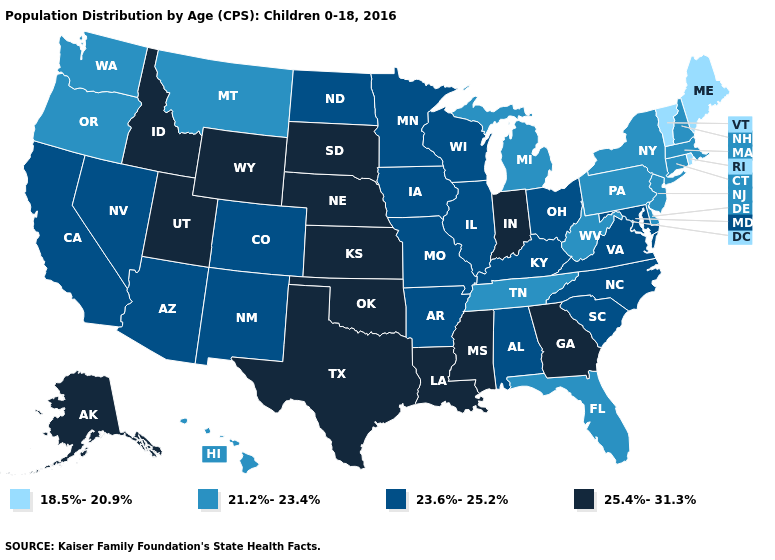Among the states that border Idaho , which have the highest value?
Be succinct. Utah, Wyoming. Does the first symbol in the legend represent the smallest category?
Concise answer only. Yes. Name the states that have a value in the range 18.5%-20.9%?
Keep it brief. Maine, Rhode Island, Vermont. Which states have the highest value in the USA?
Short answer required. Alaska, Georgia, Idaho, Indiana, Kansas, Louisiana, Mississippi, Nebraska, Oklahoma, South Dakota, Texas, Utah, Wyoming. What is the highest value in the USA?
Quick response, please. 25.4%-31.3%. What is the highest value in the USA?
Be succinct. 25.4%-31.3%. Name the states that have a value in the range 21.2%-23.4%?
Concise answer only. Connecticut, Delaware, Florida, Hawaii, Massachusetts, Michigan, Montana, New Hampshire, New Jersey, New York, Oregon, Pennsylvania, Tennessee, Washington, West Virginia. Which states have the highest value in the USA?
Short answer required. Alaska, Georgia, Idaho, Indiana, Kansas, Louisiana, Mississippi, Nebraska, Oklahoma, South Dakota, Texas, Utah, Wyoming. What is the value of Utah?
Be succinct. 25.4%-31.3%. What is the value of Arizona?
Answer briefly. 23.6%-25.2%. Name the states that have a value in the range 25.4%-31.3%?
Concise answer only. Alaska, Georgia, Idaho, Indiana, Kansas, Louisiana, Mississippi, Nebraska, Oklahoma, South Dakota, Texas, Utah, Wyoming. Among the states that border North Carolina , does Georgia have the lowest value?
Be succinct. No. Does the first symbol in the legend represent the smallest category?
Short answer required. Yes. What is the highest value in states that border North Dakota?
Give a very brief answer. 25.4%-31.3%. Name the states that have a value in the range 21.2%-23.4%?
Give a very brief answer. Connecticut, Delaware, Florida, Hawaii, Massachusetts, Michigan, Montana, New Hampshire, New Jersey, New York, Oregon, Pennsylvania, Tennessee, Washington, West Virginia. 